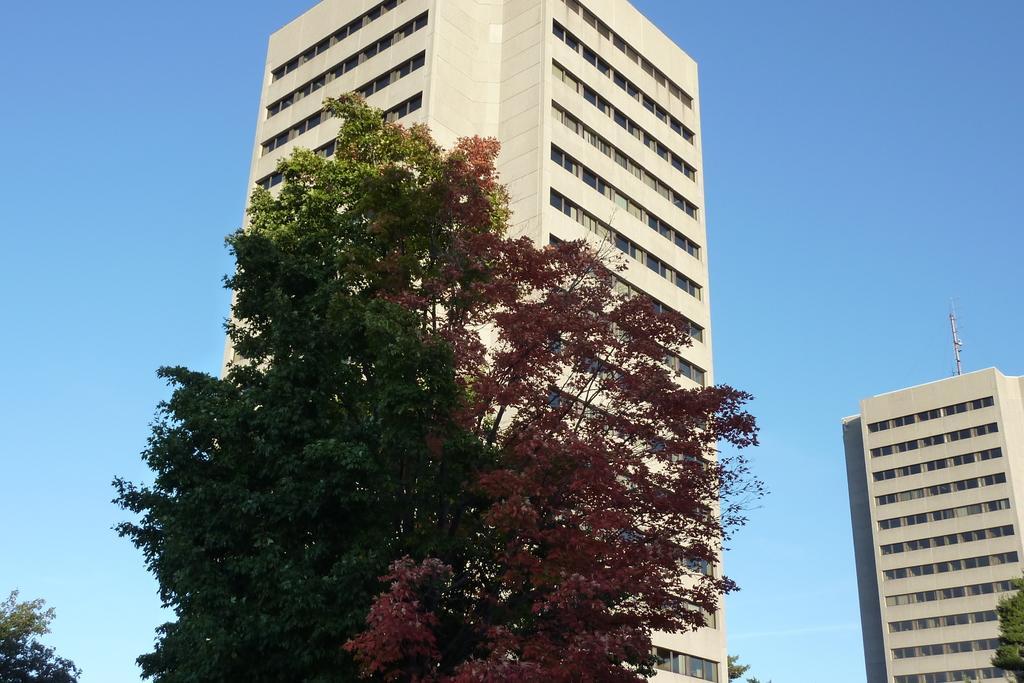Describe this image in one or two sentences. In this picture we can see buildings, trees and we can see sky in the background. 